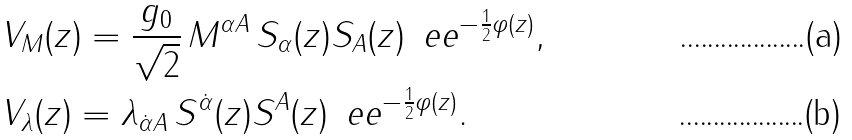Convert formula to latex. <formula><loc_0><loc_0><loc_500><loc_500>& V _ { M } ( z ) = \frac { g _ { 0 } } { \sqrt { 2 } } \, { M } ^ { \alpha A } \, S _ { \alpha } ( z ) S _ { A } ( z ) \, \ e e ^ { - \frac { 1 } { 2 } \varphi ( z ) } , \\ & V _ { \lambda } ( z ) = { { \lambda _ { \dot { \alpha } A } } } \, S ^ { \dot { \alpha } } ( z ) S ^ { A } ( z ) \, \ e e ^ { - \frac { 1 } { 2 } \varphi ( z ) } .</formula> 